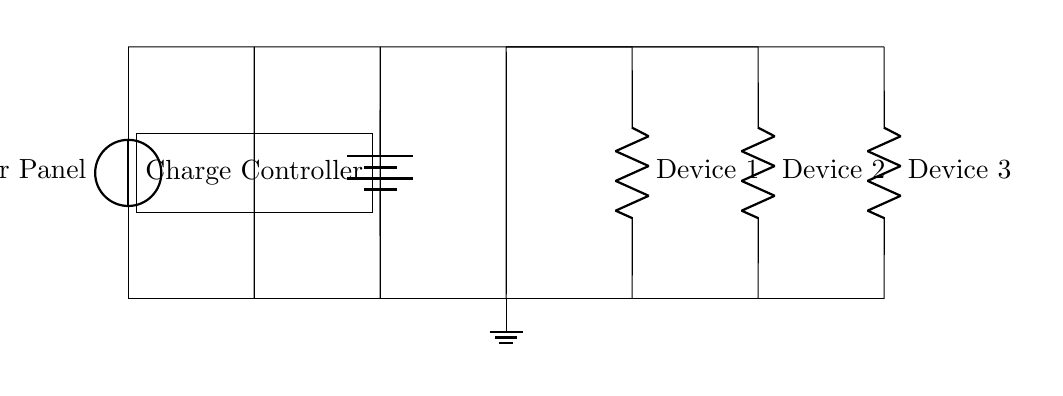What is the main component that generates power in this circuit? The main component that generates power is the solar panel, which converts sunlight into electrical energy.
Answer: solar panel What does the charge controller do in this circuit? The charge controller regulates the voltage and current flowing from the solar panel to ensure safe charging of the battery and connected devices.
Answer: regulates voltage and current How many devices are connected in parallel to the solar power circuit? There are three devices connected in parallel, allowing them to receive power simultaneously from the same source.
Answer: three What is the role of the battery in this circuit? The battery stores the electrical energy generated by the solar panel for later use, providing a steady supply of power even when sunlight is not available.
Answer: stores energy If one device fails, what happens to the other devices? If one device fails, the other devices continue to operate normally because they are connected in parallel, which provides multiple paths for the current.
Answer: operate normally Which type of circuit is depicted in this diagram? The circuit depicted in this diagram is a parallel circuit, characterized by multiple branches allowing individual devices to function independently.
Answer: parallel circuit What is the purpose of the ground in this circuit? The ground provides a reference point for the circuit's voltage and serves as a safety measure to prevent electrical shock or damage by redirecting excess current.
Answer: safety reference 